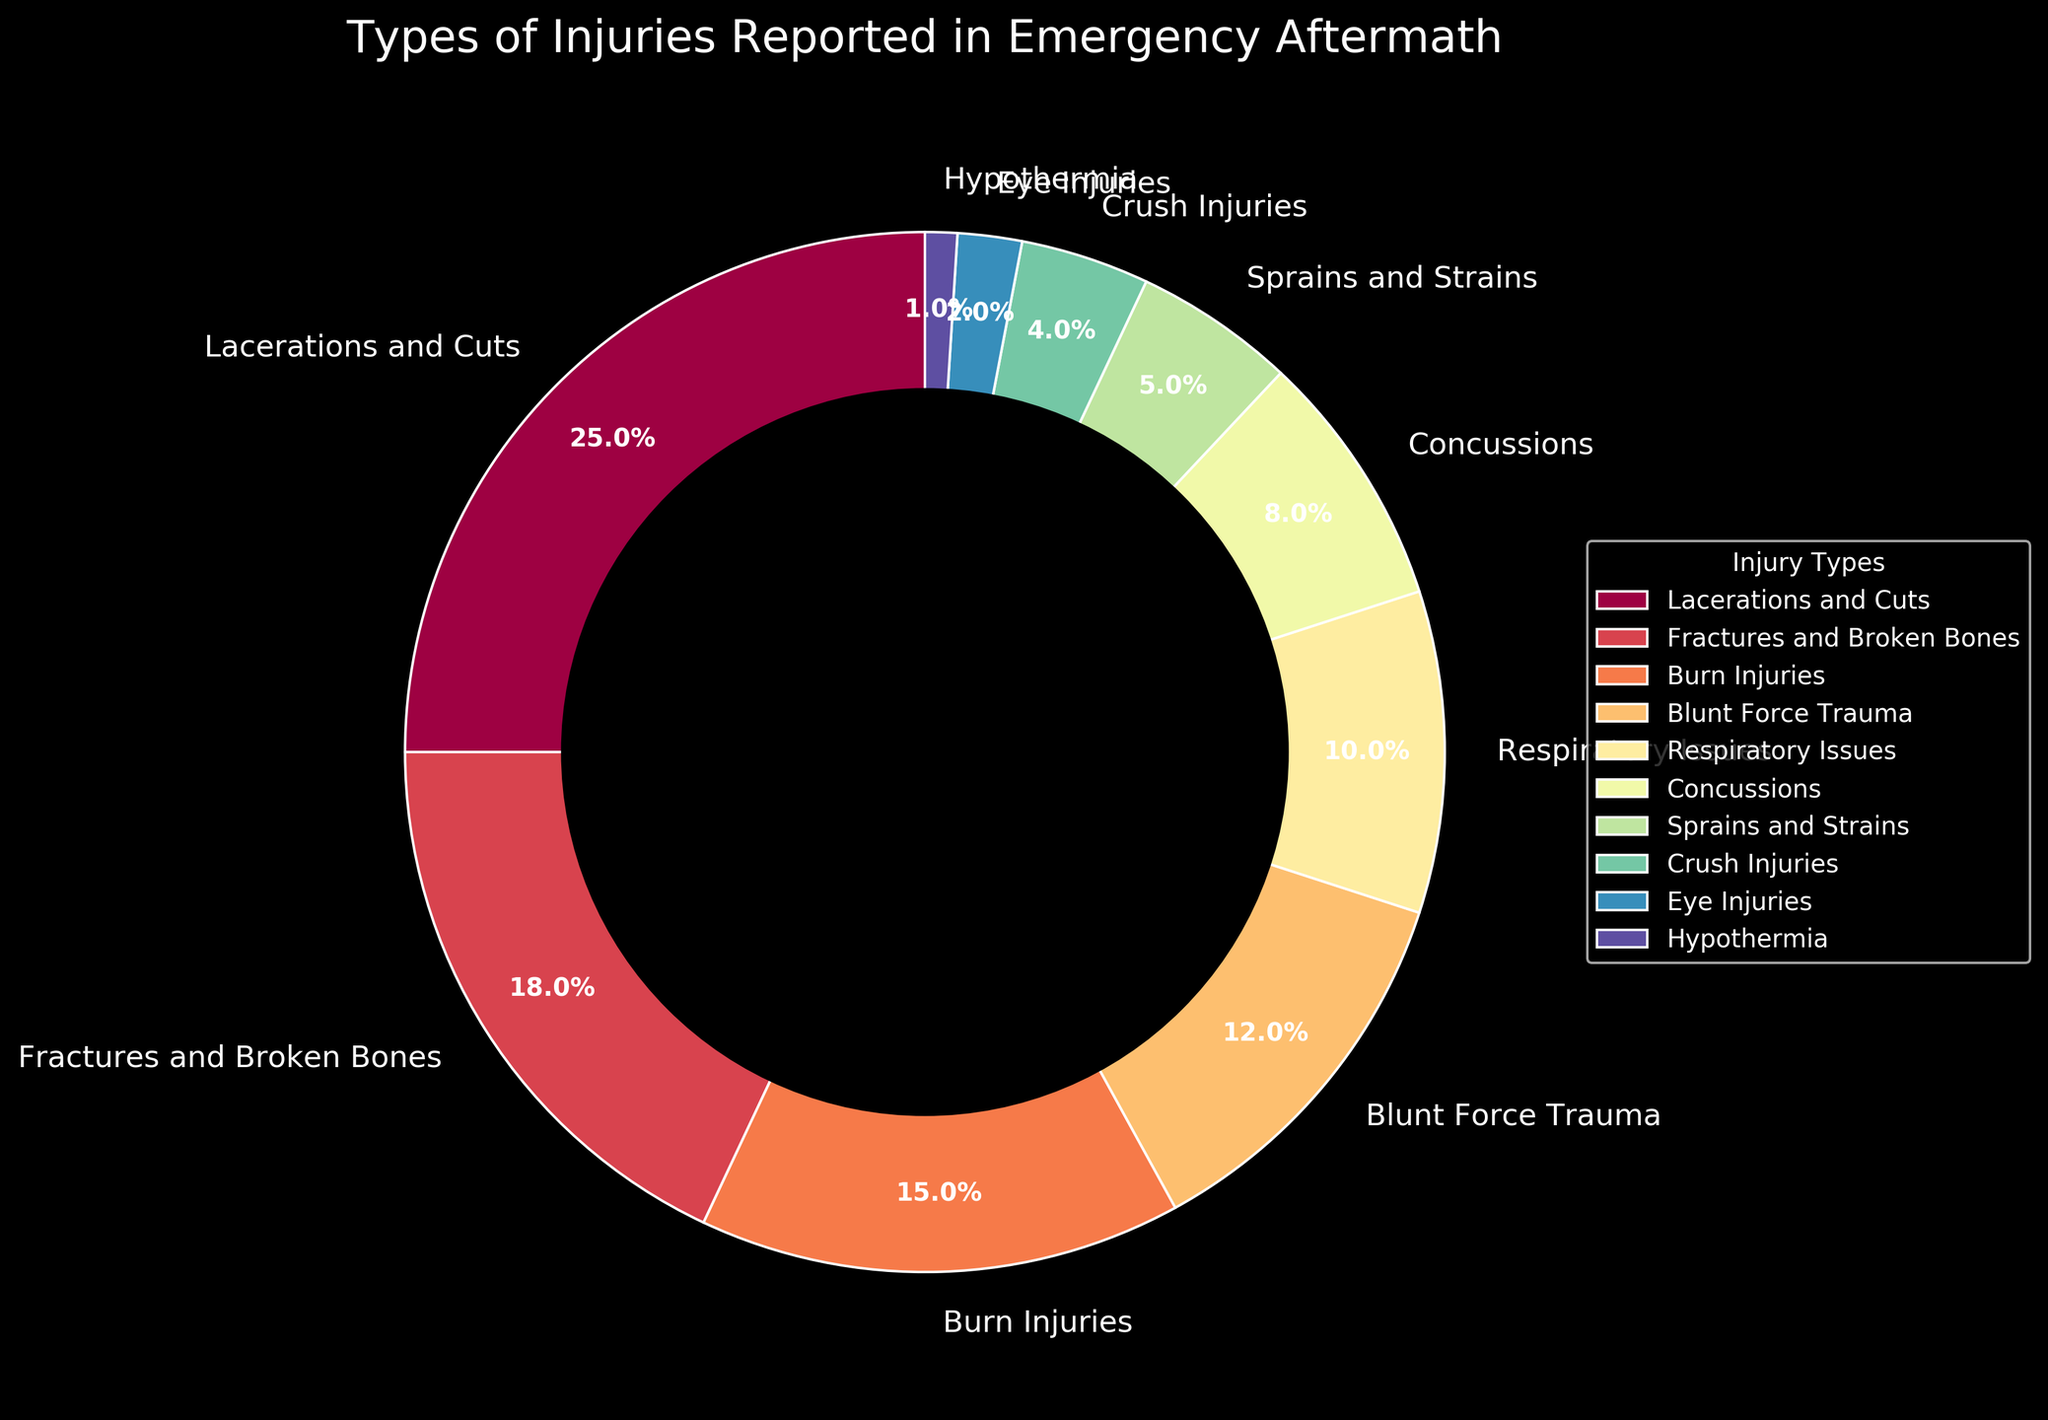What's the most common type of injury reported? The segment with the largest proportion in the pie chart represents the most common type of injury. In this case, the "Lacerations and Cuts" segment occupies the largest area.
Answer: Lacerations and Cuts What is the combined percentage of injuries due to "Fractures and Broken Bones" and "Burn Injuries"? First, find the percentages for "Fractures and Broken Bones" (18%) and "Burn Injuries" (15%). Then, add these two percentages together: 18% + 15% = 33%.
Answer: 33% Which injury type is less commonly reported than "Respiratory Issues" but more common than "Sprains and Strains"? "Respiratory Issues" is 10% and "Sprains and Strains" is 5%. Therefore, the injury type between these two is 8%, which is "Concussions".
Answer: Concussions Which two injury types together form a quarter of the injuries? We need to find two injury types whose percentages add up to 25%. "Sprains and Strains" (5%) and "Concussions" (8%) combined make only 13%, and "Hypothermia" (1%) and "Eye Injuries" (2%) combined make only 3%. Trying "Blunt Force Trauma" (12%) with "Respiratory Issues" (10%) results in 22%, which is also incorrect. Finally, "Burn Injuries" (15%) and "Crush Injuries" (4%) add up to 19% which is closer but not precise, implying no exact match in the dataset for this specific requirement.
Answer: No exact match in the dataset How much larger is the percentage of "Lacerations and Cuts" compared to "Sprains and Strains"? The percentage of "Lacerations and Cuts" is 25% and "Sprains and Strains" is 5%. Subtract 5% from 25%: 25% - 5% = 20%.
Answer: 20% What is the least common type of injury? The segment with the smallest proportion in the pie chart represents the least common type of injury. Here, it is "Hypothermia" with 1%.
Answer: Hypothermia What is the difference between the percentage of "Fractures and Broken Bones" and "Concussions"? The percentage for "Fractures and Broken Bones" is 18% and for "Concussions" it is 8%. Subtract 8% from 18%: 18% - 8% = 10%.
Answer: 10% Compare the combined percentage of "Eye Injuries" and "Hypothermia" to the percentage of "Crush Injuries". Which is higher and by how much? The combined percentage of "Eye Injuries" (2%) and "Hypothermia" (1%) is 3%. "Crush Injuries" has a percentage of 4%. To find the difference: 4% - 3% = 1%. "Crush Injuries" is higher by 1%.
Answer: Crush Injuries by 1% How do the proportions of "Burn Injuries" and "Blunt Force Trauma" compare visually? Visually, the area of the "Burn Injuries" segment (15%) is larger than the "Blunt Force Trauma" segment (12%).
Answer: Burn Injuries is larger Which injury type(s) collectively account for less than 7% of total injuries each? Check the segments that have percentages less than 7%. These are "Sprains and Strains" (5%), "Crush Injuries" (4%), "Eye Injuries" (2%), and "Hypothermia" (1%).
Answer: Sprains and Strains, Crush Injuries, Eye Injuries, Hypothermia 